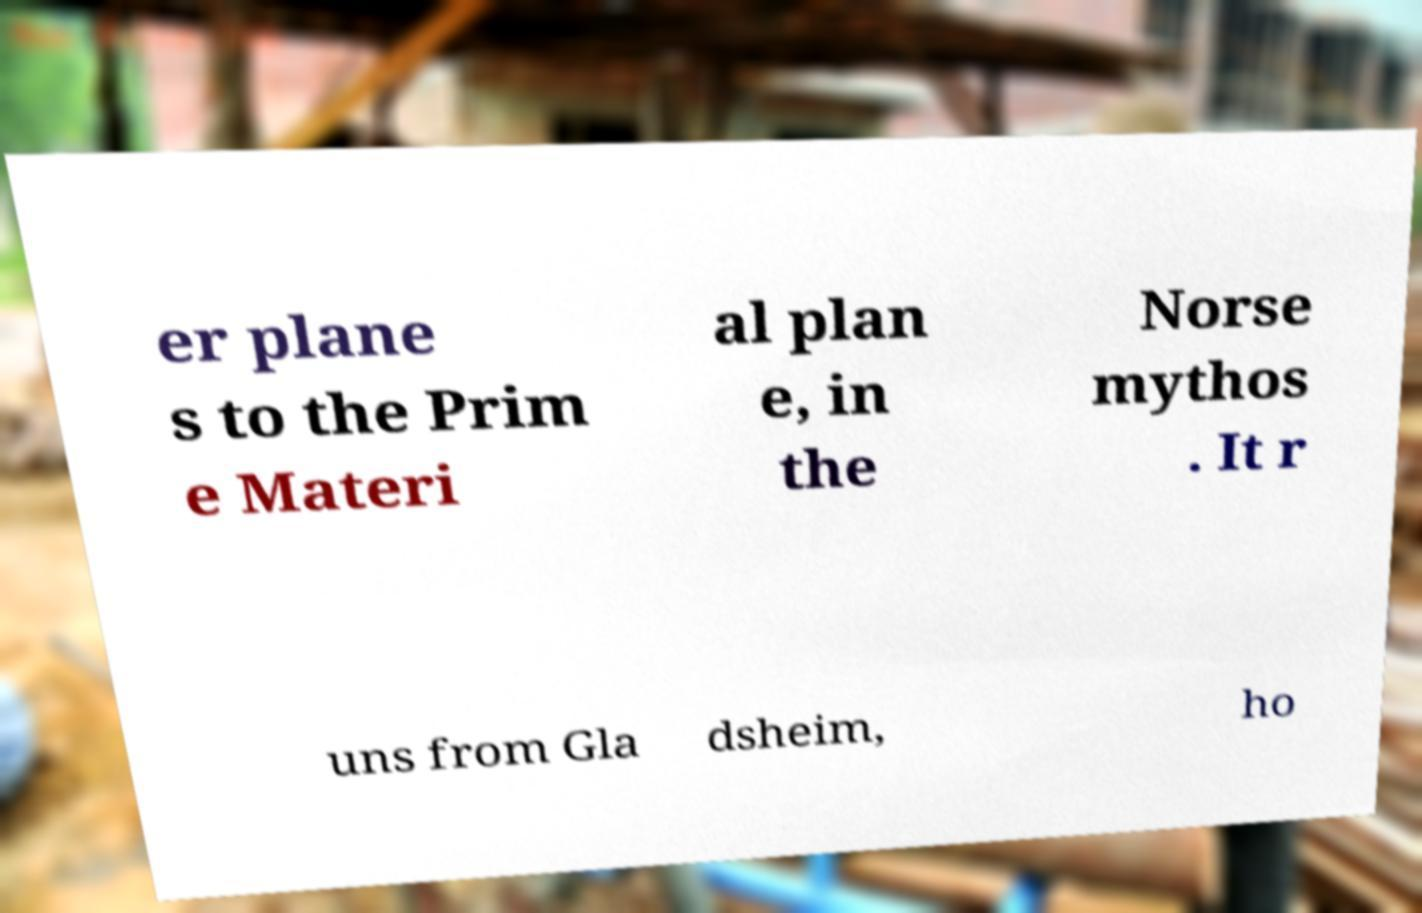There's text embedded in this image that I need extracted. Can you transcribe it verbatim? er plane s to the Prim e Materi al plan e, in the Norse mythos . It r uns from Gla dsheim, ho 